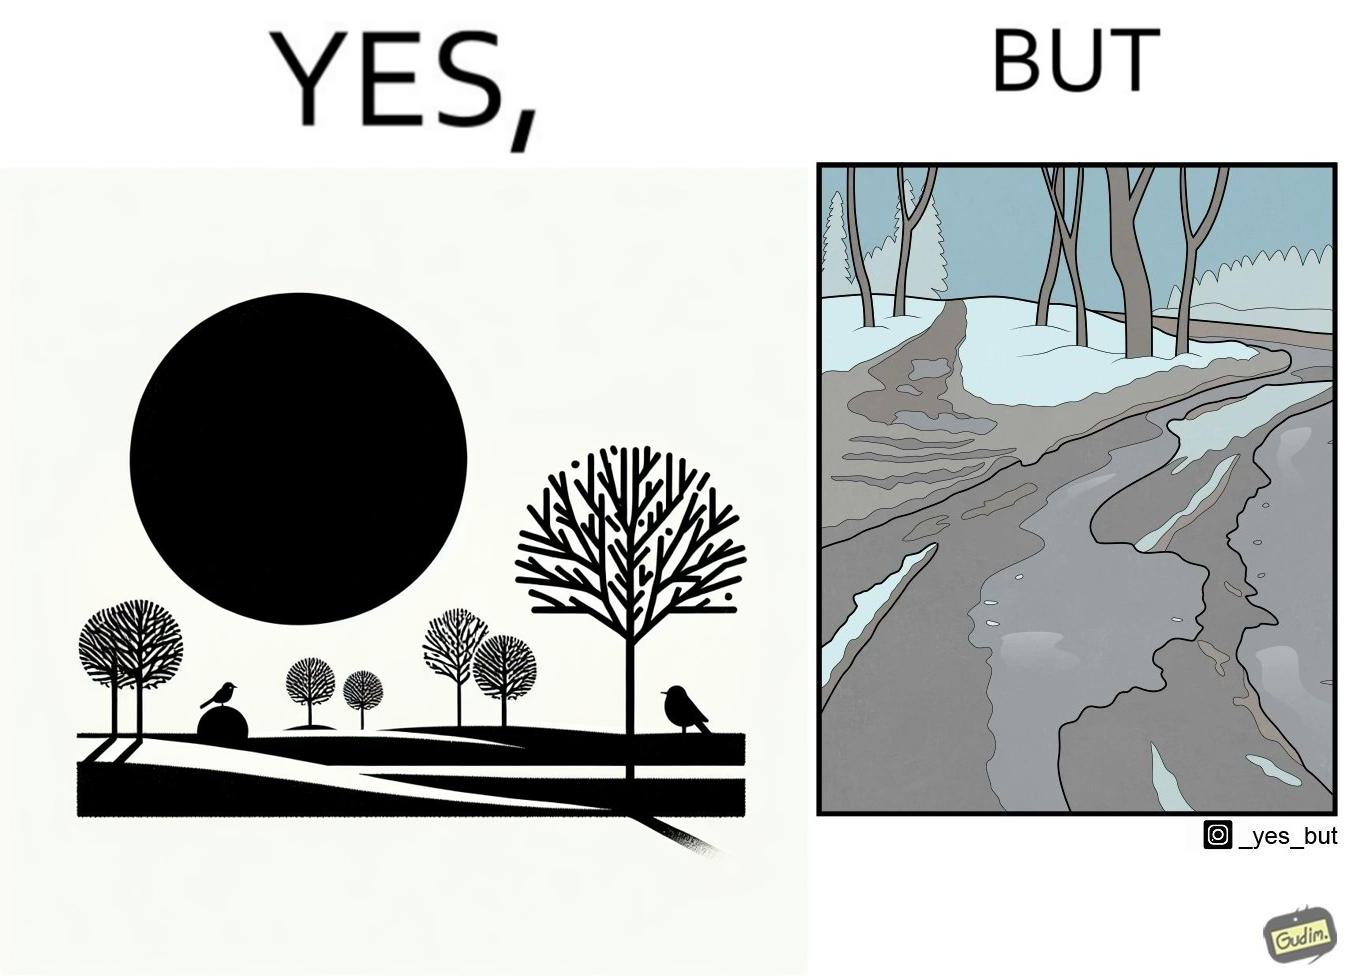What do you see in each half of this image? In the left part of the image: Trees and ground covered by snow due to snowfall, with a bird resting on a branch, and the Sun in the sky. In the right part of the image: Snow covered trees, and the ground partially covered in snow. 